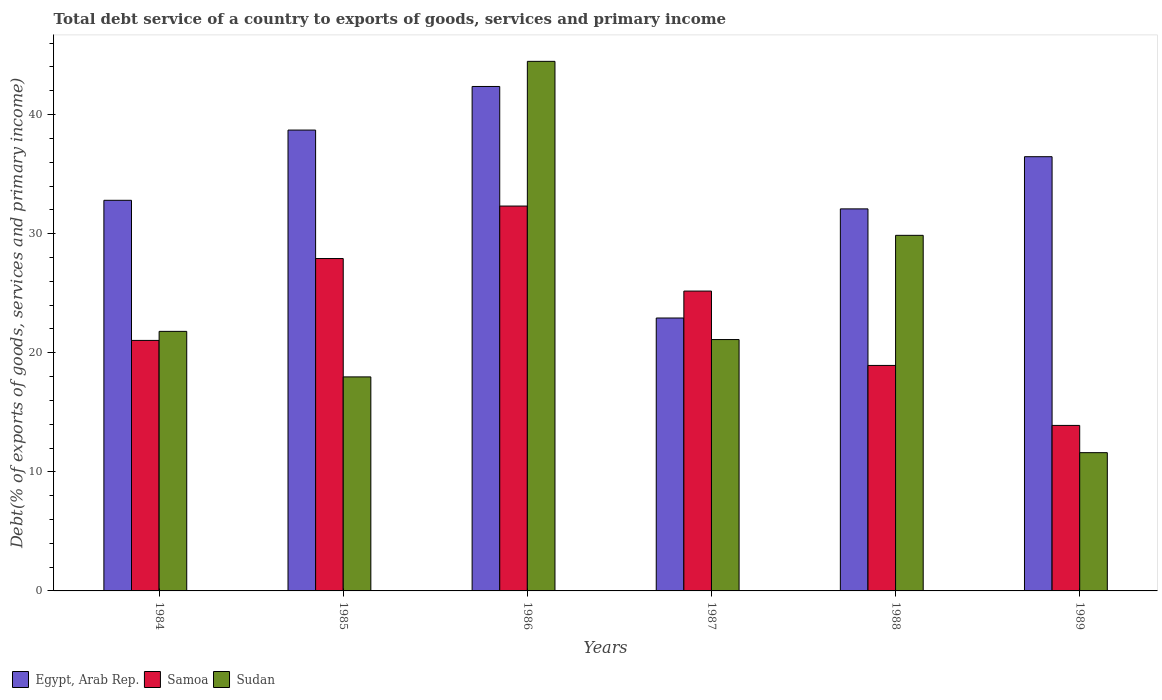How many different coloured bars are there?
Provide a short and direct response. 3. Are the number of bars per tick equal to the number of legend labels?
Provide a succinct answer. Yes. Are the number of bars on each tick of the X-axis equal?
Provide a succinct answer. Yes. What is the label of the 3rd group of bars from the left?
Your response must be concise. 1986. What is the total debt service in Egypt, Arab Rep. in 1985?
Provide a succinct answer. 38.7. Across all years, what is the maximum total debt service in Egypt, Arab Rep.?
Your answer should be compact. 42.36. Across all years, what is the minimum total debt service in Samoa?
Provide a succinct answer. 13.9. What is the total total debt service in Egypt, Arab Rep. in the graph?
Offer a very short reply. 205.34. What is the difference between the total debt service in Samoa in 1984 and that in 1986?
Keep it short and to the point. -11.28. What is the difference between the total debt service in Egypt, Arab Rep. in 1988 and the total debt service in Sudan in 1985?
Make the answer very short. 14.11. What is the average total debt service in Sudan per year?
Your answer should be very brief. 24.47. In the year 1985, what is the difference between the total debt service in Samoa and total debt service in Sudan?
Make the answer very short. 9.94. What is the ratio of the total debt service in Sudan in 1987 to that in 1988?
Give a very brief answer. 0.71. Is the total debt service in Egypt, Arab Rep. in 1984 less than that in 1986?
Offer a terse response. Yes. Is the difference between the total debt service in Samoa in 1984 and 1987 greater than the difference between the total debt service in Sudan in 1984 and 1987?
Make the answer very short. No. What is the difference between the highest and the second highest total debt service in Samoa?
Offer a terse response. 4.41. What is the difference between the highest and the lowest total debt service in Samoa?
Ensure brevity in your answer.  18.42. In how many years, is the total debt service in Egypt, Arab Rep. greater than the average total debt service in Egypt, Arab Rep. taken over all years?
Make the answer very short. 3. What does the 2nd bar from the left in 1986 represents?
Your answer should be compact. Samoa. What does the 1st bar from the right in 1988 represents?
Offer a terse response. Sudan. Is it the case that in every year, the sum of the total debt service in Samoa and total debt service in Sudan is greater than the total debt service in Egypt, Arab Rep.?
Your response must be concise. No. Are all the bars in the graph horizontal?
Your response must be concise. No. How many years are there in the graph?
Offer a very short reply. 6. What is the difference between two consecutive major ticks on the Y-axis?
Provide a succinct answer. 10. Are the values on the major ticks of Y-axis written in scientific E-notation?
Provide a short and direct response. No. Does the graph contain any zero values?
Your response must be concise. No. Does the graph contain grids?
Keep it short and to the point. No. Where does the legend appear in the graph?
Ensure brevity in your answer.  Bottom left. How many legend labels are there?
Provide a short and direct response. 3. What is the title of the graph?
Your answer should be compact. Total debt service of a country to exports of goods, services and primary income. What is the label or title of the X-axis?
Ensure brevity in your answer.  Years. What is the label or title of the Y-axis?
Your answer should be compact. Debt(% of exports of goods, services and primary income). What is the Debt(% of exports of goods, services and primary income) of Egypt, Arab Rep. in 1984?
Make the answer very short. 32.8. What is the Debt(% of exports of goods, services and primary income) in Samoa in 1984?
Offer a terse response. 21.04. What is the Debt(% of exports of goods, services and primary income) of Sudan in 1984?
Offer a terse response. 21.8. What is the Debt(% of exports of goods, services and primary income) of Egypt, Arab Rep. in 1985?
Keep it short and to the point. 38.7. What is the Debt(% of exports of goods, services and primary income) of Samoa in 1985?
Your answer should be very brief. 27.91. What is the Debt(% of exports of goods, services and primary income) in Sudan in 1985?
Your answer should be very brief. 17.97. What is the Debt(% of exports of goods, services and primary income) of Egypt, Arab Rep. in 1986?
Provide a succinct answer. 42.36. What is the Debt(% of exports of goods, services and primary income) in Samoa in 1986?
Keep it short and to the point. 32.32. What is the Debt(% of exports of goods, services and primary income) in Sudan in 1986?
Your answer should be compact. 44.47. What is the Debt(% of exports of goods, services and primary income) of Egypt, Arab Rep. in 1987?
Provide a succinct answer. 22.92. What is the Debt(% of exports of goods, services and primary income) in Samoa in 1987?
Provide a short and direct response. 25.18. What is the Debt(% of exports of goods, services and primary income) in Sudan in 1987?
Keep it short and to the point. 21.11. What is the Debt(% of exports of goods, services and primary income) in Egypt, Arab Rep. in 1988?
Offer a very short reply. 32.08. What is the Debt(% of exports of goods, services and primary income) in Samoa in 1988?
Keep it short and to the point. 18.94. What is the Debt(% of exports of goods, services and primary income) in Sudan in 1988?
Your answer should be very brief. 29.86. What is the Debt(% of exports of goods, services and primary income) of Egypt, Arab Rep. in 1989?
Make the answer very short. 36.47. What is the Debt(% of exports of goods, services and primary income) in Samoa in 1989?
Provide a succinct answer. 13.9. What is the Debt(% of exports of goods, services and primary income) of Sudan in 1989?
Keep it short and to the point. 11.61. Across all years, what is the maximum Debt(% of exports of goods, services and primary income) of Egypt, Arab Rep.?
Make the answer very short. 42.36. Across all years, what is the maximum Debt(% of exports of goods, services and primary income) of Samoa?
Give a very brief answer. 32.32. Across all years, what is the maximum Debt(% of exports of goods, services and primary income) of Sudan?
Give a very brief answer. 44.47. Across all years, what is the minimum Debt(% of exports of goods, services and primary income) in Egypt, Arab Rep.?
Make the answer very short. 22.92. Across all years, what is the minimum Debt(% of exports of goods, services and primary income) in Samoa?
Your answer should be very brief. 13.9. Across all years, what is the minimum Debt(% of exports of goods, services and primary income) in Sudan?
Make the answer very short. 11.61. What is the total Debt(% of exports of goods, services and primary income) of Egypt, Arab Rep. in the graph?
Ensure brevity in your answer.  205.34. What is the total Debt(% of exports of goods, services and primary income) of Samoa in the graph?
Your answer should be very brief. 139.29. What is the total Debt(% of exports of goods, services and primary income) of Sudan in the graph?
Keep it short and to the point. 146.83. What is the difference between the Debt(% of exports of goods, services and primary income) in Egypt, Arab Rep. in 1984 and that in 1985?
Keep it short and to the point. -5.9. What is the difference between the Debt(% of exports of goods, services and primary income) in Samoa in 1984 and that in 1985?
Ensure brevity in your answer.  -6.88. What is the difference between the Debt(% of exports of goods, services and primary income) of Sudan in 1984 and that in 1985?
Your answer should be compact. 3.82. What is the difference between the Debt(% of exports of goods, services and primary income) of Egypt, Arab Rep. in 1984 and that in 1986?
Your answer should be compact. -9.56. What is the difference between the Debt(% of exports of goods, services and primary income) of Samoa in 1984 and that in 1986?
Your answer should be compact. -11.28. What is the difference between the Debt(% of exports of goods, services and primary income) of Sudan in 1984 and that in 1986?
Ensure brevity in your answer.  -22.68. What is the difference between the Debt(% of exports of goods, services and primary income) of Egypt, Arab Rep. in 1984 and that in 1987?
Give a very brief answer. 9.89. What is the difference between the Debt(% of exports of goods, services and primary income) in Samoa in 1984 and that in 1987?
Your response must be concise. -4.14. What is the difference between the Debt(% of exports of goods, services and primary income) in Sudan in 1984 and that in 1987?
Give a very brief answer. 0.69. What is the difference between the Debt(% of exports of goods, services and primary income) of Egypt, Arab Rep. in 1984 and that in 1988?
Your response must be concise. 0.72. What is the difference between the Debt(% of exports of goods, services and primary income) in Samoa in 1984 and that in 1988?
Offer a very short reply. 2.1. What is the difference between the Debt(% of exports of goods, services and primary income) in Sudan in 1984 and that in 1988?
Keep it short and to the point. -8.06. What is the difference between the Debt(% of exports of goods, services and primary income) in Egypt, Arab Rep. in 1984 and that in 1989?
Your answer should be compact. -3.66. What is the difference between the Debt(% of exports of goods, services and primary income) of Samoa in 1984 and that in 1989?
Keep it short and to the point. 7.14. What is the difference between the Debt(% of exports of goods, services and primary income) of Sudan in 1984 and that in 1989?
Provide a succinct answer. 10.19. What is the difference between the Debt(% of exports of goods, services and primary income) of Egypt, Arab Rep. in 1985 and that in 1986?
Give a very brief answer. -3.66. What is the difference between the Debt(% of exports of goods, services and primary income) of Samoa in 1985 and that in 1986?
Offer a very short reply. -4.41. What is the difference between the Debt(% of exports of goods, services and primary income) of Sudan in 1985 and that in 1986?
Give a very brief answer. -26.5. What is the difference between the Debt(% of exports of goods, services and primary income) of Egypt, Arab Rep. in 1985 and that in 1987?
Ensure brevity in your answer.  15.78. What is the difference between the Debt(% of exports of goods, services and primary income) of Samoa in 1985 and that in 1987?
Your answer should be compact. 2.73. What is the difference between the Debt(% of exports of goods, services and primary income) in Sudan in 1985 and that in 1987?
Your response must be concise. -3.14. What is the difference between the Debt(% of exports of goods, services and primary income) in Egypt, Arab Rep. in 1985 and that in 1988?
Provide a short and direct response. 6.62. What is the difference between the Debt(% of exports of goods, services and primary income) of Samoa in 1985 and that in 1988?
Your response must be concise. 8.98. What is the difference between the Debt(% of exports of goods, services and primary income) of Sudan in 1985 and that in 1988?
Offer a very short reply. -11.89. What is the difference between the Debt(% of exports of goods, services and primary income) of Egypt, Arab Rep. in 1985 and that in 1989?
Your answer should be very brief. 2.24. What is the difference between the Debt(% of exports of goods, services and primary income) of Samoa in 1985 and that in 1989?
Your answer should be compact. 14.01. What is the difference between the Debt(% of exports of goods, services and primary income) of Sudan in 1985 and that in 1989?
Your answer should be very brief. 6.36. What is the difference between the Debt(% of exports of goods, services and primary income) in Egypt, Arab Rep. in 1986 and that in 1987?
Your answer should be very brief. 19.45. What is the difference between the Debt(% of exports of goods, services and primary income) in Samoa in 1986 and that in 1987?
Your answer should be very brief. 7.14. What is the difference between the Debt(% of exports of goods, services and primary income) in Sudan in 1986 and that in 1987?
Make the answer very short. 23.36. What is the difference between the Debt(% of exports of goods, services and primary income) of Egypt, Arab Rep. in 1986 and that in 1988?
Your answer should be compact. 10.28. What is the difference between the Debt(% of exports of goods, services and primary income) in Samoa in 1986 and that in 1988?
Offer a very short reply. 13.38. What is the difference between the Debt(% of exports of goods, services and primary income) in Sudan in 1986 and that in 1988?
Your response must be concise. 14.61. What is the difference between the Debt(% of exports of goods, services and primary income) in Egypt, Arab Rep. in 1986 and that in 1989?
Your response must be concise. 5.9. What is the difference between the Debt(% of exports of goods, services and primary income) of Samoa in 1986 and that in 1989?
Your response must be concise. 18.42. What is the difference between the Debt(% of exports of goods, services and primary income) in Sudan in 1986 and that in 1989?
Provide a short and direct response. 32.86. What is the difference between the Debt(% of exports of goods, services and primary income) in Egypt, Arab Rep. in 1987 and that in 1988?
Provide a short and direct response. -9.17. What is the difference between the Debt(% of exports of goods, services and primary income) in Samoa in 1987 and that in 1988?
Keep it short and to the point. 6.25. What is the difference between the Debt(% of exports of goods, services and primary income) in Sudan in 1987 and that in 1988?
Offer a terse response. -8.75. What is the difference between the Debt(% of exports of goods, services and primary income) in Egypt, Arab Rep. in 1987 and that in 1989?
Make the answer very short. -13.55. What is the difference between the Debt(% of exports of goods, services and primary income) of Samoa in 1987 and that in 1989?
Give a very brief answer. 11.28. What is the difference between the Debt(% of exports of goods, services and primary income) in Sudan in 1987 and that in 1989?
Ensure brevity in your answer.  9.5. What is the difference between the Debt(% of exports of goods, services and primary income) in Egypt, Arab Rep. in 1988 and that in 1989?
Make the answer very short. -4.38. What is the difference between the Debt(% of exports of goods, services and primary income) of Samoa in 1988 and that in 1989?
Your response must be concise. 5.04. What is the difference between the Debt(% of exports of goods, services and primary income) in Sudan in 1988 and that in 1989?
Offer a terse response. 18.25. What is the difference between the Debt(% of exports of goods, services and primary income) in Egypt, Arab Rep. in 1984 and the Debt(% of exports of goods, services and primary income) in Samoa in 1985?
Your response must be concise. 4.89. What is the difference between the Debt(% of exports of goods, services and primary income) of Egypt, Arab Rep. in 1984 and the Debt(% of exports of goods, services and primary income) of Sudan in 1985?
Make the answer very short. 14.83. What is the difference between the Debt(% of exports of goods, services and primary income) in Samoa in 1984 and the Debt(% of exports of goods, services and primary income) in Sudan in 1985?
Give a very brief answer. 3.06. What is the difference between the Debt(% of exports of goods, services and primary income) in Egypt, Arab Rep. in 1984 and the Debt(% of exports of goods, services and primary income) in Samoa in 1986?
Make the answer very short. 0.48. What is the difference between the Debt(% of exports of goods, services and primary income) of Egypt, Arab Rep. in 1984 and the Debt(% of exports of goods, services and primary income) of Sudan in 1986?
Your response must be concise. -11.67. What is the difference between the Debt(% of exports of goods, services and primary income) in Samoa in 1984 and the Debt(% of exports of goods, services and primary income) in Sudan in 1986?
Make the answer very short. -23.44. What is the difference between the Debt(% of exports of goods, services and primary income) in Egypt, Arab Rep. in 1984 and the Debt(% of exports of goods, services and primary income) in Samoa in 1987?
Provide a succinct answer. 7.62. What is the difference between the Debt(% of exports of goods, services and primary income) of Egypt, Arab Rep. in 1984 and the Debt(% of exports of goods, services and primary income) of Sudan in 1987?
Your response must be concise. 11.69. What is the difference between the Debt(% of exports of goods, services and primary income) of Samoa in 1984 and the Debt(% of exports of goods, services and primary income) of Sudan in 1987?
Your answer should be very brief. -0.07. What is the difference between the Debt(% of exports of goods, services and primary income) of Egypt, Arab Rep. in 1984 and the Debt(% of exports of goods, services and primary income) of Samoa in 1988?
Give a very brief answer. 13.87. What is the difference between the Debt(% of exports of goods, services and primary income) of Egypt, Arab Rep. in 1984 and the Debt(% of exports of goods, services and primary income) of Sudan in 1988?
Keep it short and to the point. 2.94. What is the difference between the Debt(% of exports of goods, services and primary income) in Samoa in 1984 and the Debt(% of exports of goods, services and primary income) in Sudan in 1988?
Your answer should be compact. -8.82. What is the difference between the Debt(% of exports of goods, services and primary income) in Egypt, Arab Rep. in 1984 and the Debt(% of exports of goods, services and primary income) in Samoa in 1989?
Provide a succinct answer. 18.9. What is the difference between the Debt(% of exports of goods, services and primary income) in Egypt, Arab Rep. in 1984 and the Debt(% of exports of goods, services and primary income) in Sudan in 1989?
Your answer should be compact. 21.19. What is the difference between the Debt(% of exports of goods, services and primary income) of Samoa in 1984 and the Debt(% of exports of goods, services and primary income) of Sudan in 1989?
Your answer should be very brief. 9.43. What is the difference between the Debt(% of exports of goods, services and primary income) in Egypt, Arab Rep. in 1985 and the Debt(% of exports of goods, services and primary income) in Samoa in 1986?
Offer a very short reply. 6.38. What is the difference between the Debt(% of exports of goods, services and primary income) of Egypt, Arab Rep. in 1985 and the Debt(% of exports of goods, services and primary income) of Sudan in 1986?
Provide a short and direct response. -5.77. What is the difference between the Debt(% of exports of goods, services and primary income) in Samoa in 1985 and the Debt(% of exports of goods, services and primary income) in Sudan in 1986?
Your response must be concise. -16.56. What is the difference between the Debt(% of exports of goods, services and primary income) in Egypt, Arab Rep. in 1985 and the Debt(% of exports of goods, services and primary income) in Samoa in 1987?
Provide a succinct answer. 13.52. What is the difference between the Debt(% of exports of goods, services and primary income) of Egypt, Arab Rep. in 1985 and the Debt(% of exports of goods, services and primary income) of Sudan in 1987?
Give a very brief answer. 17.59. What is the difference between the Debt(% of exports of goods, services and primary income) of Samoa in 1985 and the Debt(% of exports of goods, services and primary income) of Sudan in 1987?
Your answer should be very brief. 6.8. What is the difference between the Debt(% of exports of goods, services and primary income) of Egypt, Arab Rep. in 1985 and the Debt(% of exports of goods, services and primary income) of Samoa in 1988?
Your answer should be compact. 19.77. What is the difference between the Debt(% of exports of goods, services and primary income) in Egypt, Arab Rep. in 1985 and the Debt(% of exports of goods, services and primary income) in Sudan in 1988?
Your answer should be very brief. 8.84. What is the difference between the Debt(% of exports of goods, services and primary income) in Samoa in 1985 and the Debt(% of exports of goods, services and primary income) in Sudan in 1988?
Your answer should be compact. -1.95. What is the difference between the Debt(% of exports of goods, services and primary income) of Egypt, Arab Rep. in 1985 and the Debt(% of exports of goods, services and primary income) of Samoa in 1989?
Offer a terse response. 24.8. What is the difference between the Debt(% of exports of goods, services and primary income) in Egypt, Arab Rep. in 1985 and the Debt(% of exports of goods, services and primary income) in Sudan in 1989?
Your answer should be compact. 27.09. What is the difference between the Debt(% of exports of goods, services and primary income) in Samoa in 1985 and the Debt(% of exports of goods, services and primary income) in Sudan in 1989?
Offer a terse response. 16.3. What is the difference between the Debt(% of exports of goods, services and primary income) in Egypt, Arab Rep. in 1986 and the Debt(% of exports of goods, services and primary income) in Samoa in 1987?
Provide a short and direct response. 17.18. What is the difference between the Debt(% of exports of goods, services and primary income) of Egypt, Arab Rep. in 1986 and the Debt(% of exports of goods, services and primary income) of Sudan in 1987?
Provide a succinct answer. 21.25. What is the difference between the Debt(% of exports of goods, services and primary income) of Samoa in 1986 and the Debt(% of exports of goods, services and primary income) of Sudan in 1987?
Give a very brief answer. 11.21. What is the difference between the Debt(% of exports of goods, services and primary income) of Egypt, Arab Rep. in 1986 and the Debt(% of exports of goods, services and primary income) of Samoa in 1988?
Your answer should be very brief. 23.43. What is the difference between the Debt(% of exports of goods, services and primary income) of Egypt, Arab Rep. in 1986 and the Debt(% of exports of goods, services and primary income) of Sudan in 1988?
Make the answer very short. 12.5. What is the difference between the Debt(% of exports of goods, services and primary income) in Samoa in 1986 and the Debt(% of exports of goods, services and primary income) in Sudan in 1988?
Provide a short and direct response. 2.46. What is the difference between the Debt(% of exports of goods, services and primary income) of Egypt, Arab Rep. in 1986 and the Debt(% of exports of goods, services and primary income) of Samoa in 1989?
Ensure brevity in your answer.  28.46. What is the difference between the Debt(% of exports of goods, services and primary income) in Egypt, Arab Rep. in 1986 and the Debt(% of exports of goods, services and primary income) in Sudan in 1989?
Your answer should be very brief. 30.75. What is the difference between the Debt(% of exports of goods, services and primary income) in Samoa in 1986 and the Debt(% of exports of goods, services and primary income) in Sudan in 1989?
Your response must be concise. 20.71. What is the difference between the Debt(% of exports of goods, services and primary income) of Egypt, Arab Rep. in 1987 and the Debt(% of exports of goods, services and primary income) of Samoa in 1988?
Offer a very short reply. 3.98. What is the difference between the Debt(% of exports of goods, services and primary income) of Egypt, Arab Rep. in 1987 and the Debt(% of exports of goods, services and primary income) of Sudan in 1988?
Your answer should be compact. -6.94. What is the difference between the Debt(% of exports of goods, services and primary income) of Samoa in 1987 and the Debt(% of exports of goods, services and primary income) of Sudan in 1988?
Your answer should be compact. -4.68. What is the difference between the Debt(% of exports of goods, services and primary income) of Egypt, Arab Rep. in 1987 and the Debt(% of exports of goods, services and primary income) of Samoa in 1989?
Your response must be concise. 9.02. What is the difference between the Debt(% of exports of goods, services and primary income) in Egypt, Arab Rep. in 1987 and the Debt(% of exports of goods, services and primary income) in Sudan in 1989?
Your answer should be very brief. 11.31. What is the difference between the Debt(% of exports of goods, services and primary income) of Samoa in 1987 and the Debt(% of exports of goods, services and primary income) of Sudan in 1989?
Give a very brief answer. 13.57. What is the difference between the Debt(% of exports of goods, services and primary income) in Egypt, Arab Rep. in 1988 and the Debt(% of exports of goods, services and primary income) in Samoa in 1989?
Keep it short and to the point. 18.18. What is the difference between the Debt(% of exports of goods, services and primary income) of Egypt, Arab Rep. in 1988 and the Debt(% of exports of goods, services and primary income) of Sudan in 1989?
Offer a very short reply. 20.47. What is the difference between the Debt(% of exports of goods, services and primary income) in Samoa in 1988 and the Debt(% of exports of goods, services and primary income) in Sudan in 1989?
Provide a short and direct response. 7.33. What is the average Debt(% of exports of goods, services and primary income) of Egypt, Arab Rep. per year?
Keep it short and to the point. 34.22. What is the average Debt(% of exports of goods, services and primary income) in Samoa per year?
Offer a very short reply. 23.22. What is the average Debt(% of exports of goods, services and primary income) of Sudan per year?
Your response must be concise. 24.47. In the year 1984, what is the difference between the Debt(% of exports of goods, services and primary income) in Egypt, Arab Rep. and Debt(% of exports of goods, services and primary income) in Samoa?
Your answer should be very brief. 11.77. In the year 1984, what is the difference between the Debt(% of exports of goods, services and primary income) in Egypt, Arab Rep. and Debt(% of exports of goods, services and primary income) in Sudan?
Provide a succinct answer. 11.01. In the year 1984, what is the difference between the Debt(% of exports of goods, services and primary income) of Samoa and Debt(% of exports of goods, services and primary income) of Sudan?
Offer a terse response. -0.76. In the year 1985, what is the difference between the Debt(% of exports of goods, services and primary income) in Egypt, Arab Rep. and Debt(% of exports of goods, services and primary income) in Samoa?
Your answer should be very brief. 10.79. In the year 1985, what is the difference between the Debt(% of exports of goods, services and primary income) of Egypt, Arab Rep. and Debt(% of exports of goods, services and primary income) of Sudan?
Provide a succinct answer. 20.73. In the year 1985, what is the difference between the Debt(% of exports of goods, services and primary income) of Samoa and Debt(% of exports of goods, services and primary income) of Sudan?
Offer a very short reply. 9.94. In the year 1986, what is the difference between the Debt(% of exports of goods, services and primary income) of Egypt, Arab Rep. and Debt(% of exports of goods, services and primary income) of Samoa?
Ensure brevity in your answer.  10.04. In the year 1986, what is the difference between the Debt(% of exports of goods, services and primary income) of Egypt, Arab Rep. and Debt(% of exports of goods, services and primary income) of Sudan?
Offer a terse response. -2.11. In the year 1986, what is the difference between the Debt(% of exports of goods, services and primary income) of Samoa and Debt(% of exports of goods, services and primary income) of Sudan?
Keep it short and to the point. -12.15. In the year 1987, what is the difference between the Debt(% of exports of goods, services and primary income) in Egypt, Arab Rep. and Debt(% of exports of goods, services and primary income) in Samoa?
Your answer should be very brief. -2.26. In the year 1987, what is the difference between the Debt(% of exports of goods, services and primary income) in Egypt, Arab Rep. and Debt(% of exports of goods, services and primary income) in Sudan?
Offer a terse response. 1.81. In the year 1987, what is the difference between the Debt(% of exports of goods, services and primary income) in Samoa and Debt(% of exports of goods, services and primary income) in Sudan?
Keep it short and to the point. 4.07. In the year 1988, what is the difference between the Debt(% of exports of goods, services and primary income) of Egypt, Arab Rep. and Debt(% of exports of goods, services and primary income) of Samoa?
Provide a succinct answer. 13.15. In the year 1988, what is the difference between the Debt(% of exports of goods, services and primary income) in Egypt, Arab Rep. and Debt(% of exports of goods, services and primary income) in Sudan?
Your response must be concise. 2.22. In the year 1988, what is the difference between the Debt(% of exports of goods, services and primary income) in Samoa and Debt(% of exports of goods, services and primary income) in Sudan?
Your answer should be compact. -10.93. In the year 1989, what is the difference between the Debt(% of exports of goods, services and primary income) of Egypt, Arab Rep. and Debt(% of exports of goods, services and primary income) of Samoa?
Ensure brevity in your answer.  22.57. In the year 1989, what is the difference between the Debt(% of exports of goods, services and primary income) in Egypt, Arab Rep. and Debt(% of exports of goods, services and primary income) in Sudan?
Provide a succinct answer. 24.86. In the year 1989, what is the difference between the Debt(% of exports of goods, services and primary income) in Samoa and Debt(% of exports of goods, services and primary income) in Sudan?
Your response must be concise. 2.29. What is the ratio of the Debt(% of exports of goods, services and primary income) of Egypt, Arab Rep. in 1984 to that in 1985?
Keep it short and to the point. 0.85. What is the ratio of the Debt(% of exports of goods, services and primary income) in Samoa in 1984 to that in 1985?
Your response must be concise. 0.75. What is the ratio of the Debt(% of exports of goods, services and primary income) of Sudan in 1984 to that in 1985?
Offer a terse response. 1.21. What is the ratio of the Debt(% of exports of goods, services and primary income) in Egypt, Arab Rep. in 1984 to that in 1986?
Keep it short and to the point. 0.77. What is the ratio of the Debt(% of exports of goods, services and primary income) in Samoa in 1984 to that in 1986?
Your answer should be very brief. 0.65. What is the ratio of the Debt(% of exports of goods, services and primary income) in Sudan in 1984 to that in 1986?
Offer a terse response. 0.49. What is the ratio of the Debt(% of exports of goods, services and primary income) in Egypt, Arab Rep. in 1984 to that in 1987?
Your answer should be very brief. 1.43. What is the ratio of the Debt(% of exports of goods, services and primary income) in Samoa in 1984 to that in 1987?
Your response must be concise. 0.84. What is the ratio of the Debt(% of exports of goods, services and primary income) in Sudan in 1984 to that in 1987?
Ensure brevity in your answer.  1.03. What is the ratio of the Debt(% of exports of goods, services and primary income) in Egypt, Arab Rep. in 1984 to that in 1988?
Your answer should be compact. 1.02. What is the ratio of the Debt(% of exports of goods, services and primary income) in Samoa in 1984 to that in 1988?
Ensure brevity in your answer.  1.11. What is the ratio of the Debt(% of exports of goods, services and primary income) in Sudan in 1984 to that in 1988?
Make the answer very short. 0.73. What is the ratio of the Debt(% of exports of goods, services and primary income) in Egypt, Arab Rep. in 1984 to that in 1989?
Make the answer very short. 0.9. What is the ratio of the Debt(% of exports of goods, services and primary income) of Samoa in 1984 to that in 1989?
Offer a very short reply. 1.51. What is the ratio of the Debt(% of exports of goods, services and primary income) in Sudan in 1984 to that in 1989?
Give a very brief answer. 1.88. What is the ratio of the Debt(% of exports of goods, services and primary income) in Egypt, Arab Rep. in 1985 to that in 1986?
Your answer should be very brief. 0.91. What is the ratio of the Debt(% of exports of goods, services and primary income) of Samoa in 1985 to that in 1986?
Your answer should be very brief. 0.86. What is the ratio of the Debt(% of exports of goods, services and primary income) of Sudan in 1985 to that in 1986?
Offer a terse response. 0.4. What is the ratio of the Debt(% of exports of goods, services and primary income) of Egypt, Arab Rep. in 1985 to that in 1987?
Keep it short and to the point. 1.69. What is the ratio of the Debt(% of exports of goods, services and primary income) in Samoa in 1985 to that in 1987?
Make the answer very short. 1.11. What is the ratio of the Debt(% of exports of goods, services and primary income) in Sudan in 1985 to that in 1987?
Provide a succinct answer. 0.85. What is the ratio of the Debt(% of exports of goods, services and primary income) in Egypt, Arab Rep. in 1985 to that in 1988?
Keep it short and to the point. 1.21. What is the ratio of the Debt(% of exports of goods, services and primary income) of Samoa in 1985 to that in 1988?
Keep it short and to the point. 1.47. What is the ratio of the Debt(% of exports of goods, services and primary income) in Sudan in 1985 to that in 1988?
Keep it short and to the point. 0.6. What is the ratio of the Debt(% of exports of goods, services and primary income) in Egypt, Arab Rep. in 1985 to that in 1989?
Provide a short and direct response. 1.06. What is the ratio of the Debt(% of exports of goods, services and primary income) in Samoa in 1985 to that in 1989?
Keep it short and to the point. 2.01. What is the ratio of the Debt(% of exports of goods, services and primary income) of Sudan in 1985 to that in 1989?
Make the answer very short. 1.55. What is the ratio of the Debt(% of exports of goods, services and primary income) of Egypt, Arab Rep. in 1986 to that in 1987?
Provide a succinct answer. 1.85. What is the ratio of the Debt(% of exports of goods, services and primary income) in Samoa in 1986 to that in 1987?
Keep it short and to the point. 1.28. What is the ratio of the Debt(% of exports of goods, services and primary income) in Sudan in 1986 to that in 1987?
Keep it short and to the point. 2.11. What is the ratio of the Debt(% of exports of goods, services and primary income) of Egypt, Arab Rep. in 1986 to that in 1988?
Your answer should be compact. 1.32. What is the ratio of the Debt(% of exports of goods, services and primary income) in Samoa in 1986 to that in 1988?
Ensure brevity in your answer.  1.71. What is the ratio of the Debt(% of exports of goods, services and primary income) in Sudan in 1986 to that in 1988?
Your answer should be very brief. 1.49. What is the ratio of the Debt(% of exports of goods, services and primary income) of Egypt, Arab Rep. in 1986 to that in 1989?
Your response must be concise. 1.16. What is the ratio of the Debt(% of exports of goods, services and primary income) in Samoa in 1986 to that in 1989?
Your answer should be very brief. 2.33. What is the ratio of the Debt(% of exports of goods, services and primary income) of Sudan in 1986 to that in 1989?
Give a very brief answer. 3.83. What is the ratio of the Debt(% of exports of goods, services and primary income) of Egypt, Arab Rep. in 1987 to that in 1988?
Offer a terse response. 0.71. What is the ratio of the Debt(% of exports of goods, services and primary income) in Samoa in 1987 to that in 1988?
Your response must be concise. 1.33. What is the ratio of the Debt(% of exports of goods, services and primary income) in Sudan in 1987 to that in 1988?
Your response must be concise. 0.71. What is the ratio of the Debt(% of exports of goods, services and primary income) in Egypt, Arab Rep. in 1987 to that in 1989?
Offer a very short reply. 0.63. What is the ratio of the Debt(% of exports of goods, services and primary income) in Samoa in 1987 to that in 1989?
Your answer should be compact. 1.81. What is the ratio of the Debt(% of exports of goods, services and primary income) of Sudan in 1987 to that in 1989?
Provide a short and direct response. 1.82. What is the ratio of the Debt(% of exports of goods, services and primary income) of Egypt, Arab Rep. in 1988 to that in 1989?
Provide a succinct answer. 0.88. What is the ratio of the Debt(% of exports of goods, services and primary income) of Samoa in 1988 to that in 1989?
Give a very brief answer. 1.36. What is the ratio of the Debt(% of exports of goods, services and primary income) of Sudan in 1988 to that in 1989?
Provide a succinct answer. 2.57. What is the difference between the highest and the second highest Debt(% of exports of goods, services and primary income) of Egypt, Arab Rep.?
Give a very brief answer. 3.66. What is the difference between the highest and the second highest Debt(% of exports of goods, services and primary income) of Samoa?
Your answer should be compact. 4.41. What is the difference between the highest and the second highest Debt(% of exports of goods, services and primary income) of Sudan?
Give a very brief answer. 14.61. What is the difference between the highest and the lowest Debt(% of exports of goods, services and primary income) in Egypt, Arab Rep.?
Ensure brevity in your answer.  19.45. What is the difference between the highest and the lowest Debt(% of exports of goods, services and primary income) in Samoa?
Provide a short and direct response. 18.42. What is the difference between the highest and the lowest Debt(% of exports of goods, services and primary income) in Sudan?
Offer a very short reply. 32.86. 